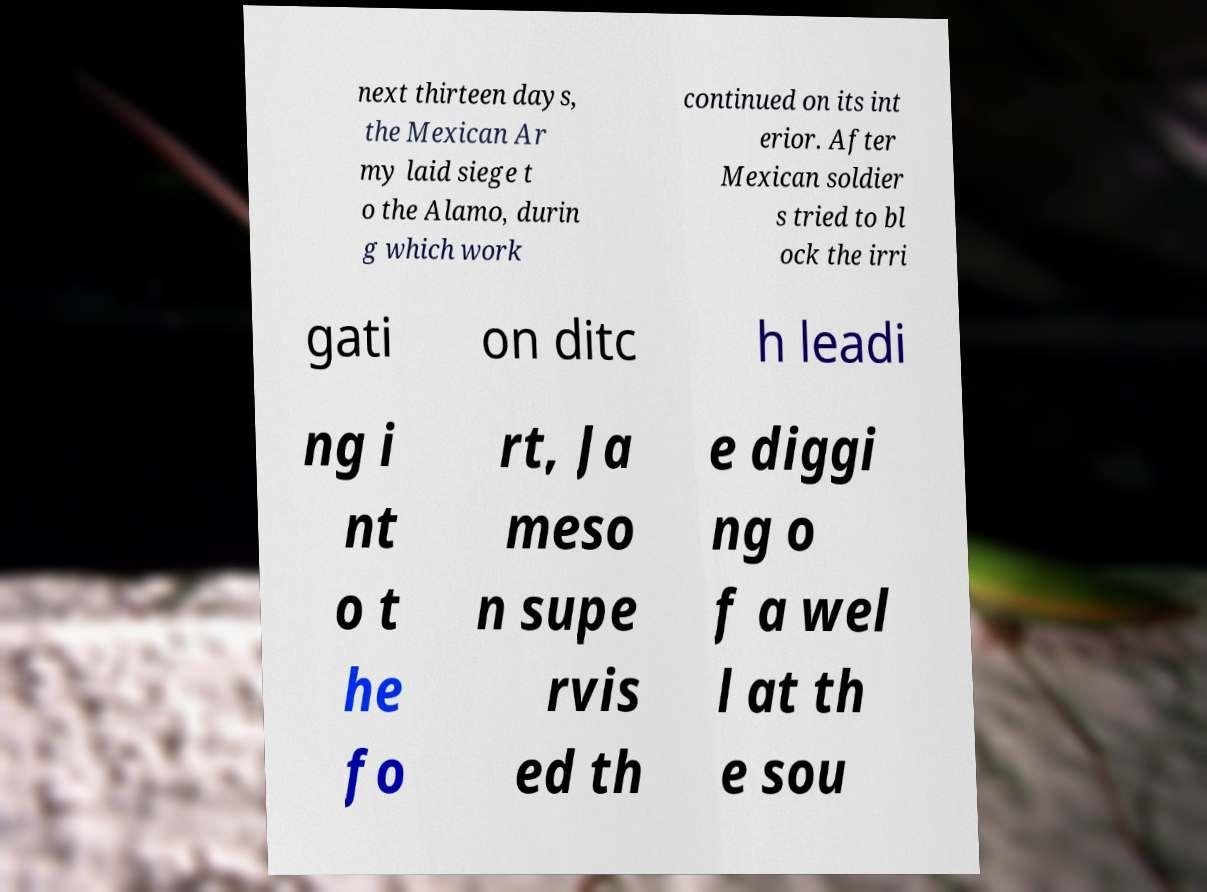Please read and relay the text visible in this image. What does it say? next thirteen days, the Mexican Ar my laid siege t o the Alamo, durin g which work continued on its int erior. After Mexican soldier s tried to bl ock the irri gati on ditc h leadi ng i nt o t he fo rt, Ja meso n supe rvis ed th e diggi ng o f a wel l at th e sou 